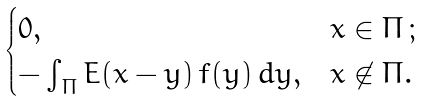Convert formula to latex. <formula><loc_0><loc_0><loc_500><loc_500>\begin{cases} 0 , & x \in \Pi \, ; \\ - \int _ { \Pi } E ( x - y ) \, f ( y ) \, d y , & x \not \in \Pi . \end{cases}</formula> 